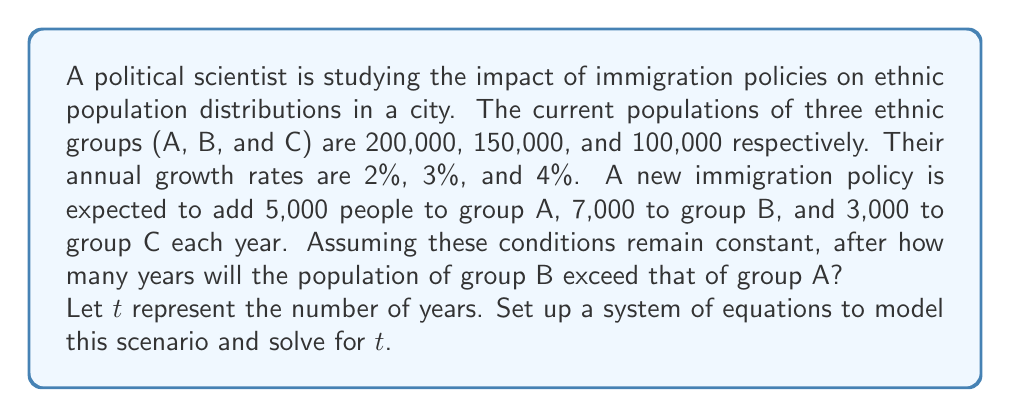Could you help me with this problem? Let's approach this step-by-step:

1) First, we need to set up equations for the population of each group after $t$ years:

   Group A: $A(t) = 200000(1.02)^t + 5000t$
   Group B: $B(t) = 150000(1.03)^t + 7000t$
   Group C: $C(t) = 100000(1.04)^t + 3000t$

2) We're interested in when B exceeds A, so we set up the equation:

   $B(t) = A(t)$

3) Substituting our expressions:

   $150000(1.03)^t + 7000t = 200000(1.02)^t + 5000t$

4) Rearranging terms:

   $150000(1.03)^t - 200000(1.02)^t = 5000t - 7000t$
   $150000(1.03)^t - 200000(1.02)^t = -2000t$

5) This equation can't be solved algebraically. We need to use numerical methods or graphing to find the solution.

6) Using a graphing calculator or computer software, we can plot both sides of the equation:

   $y_1 = 150000(1.03)^t - 200000(1.02)^t$
   $y_2 = -2000t$

7) The intersection point of these two curves gives us the solution. 

8) The intersection occurs at approximately $t = 27.5$ years.

9) Since we're looking for the first year when B exceeds A, we round up to the next whole year.

Therefore, group B will exceed group A after 28 years.
Answer: 28 years 